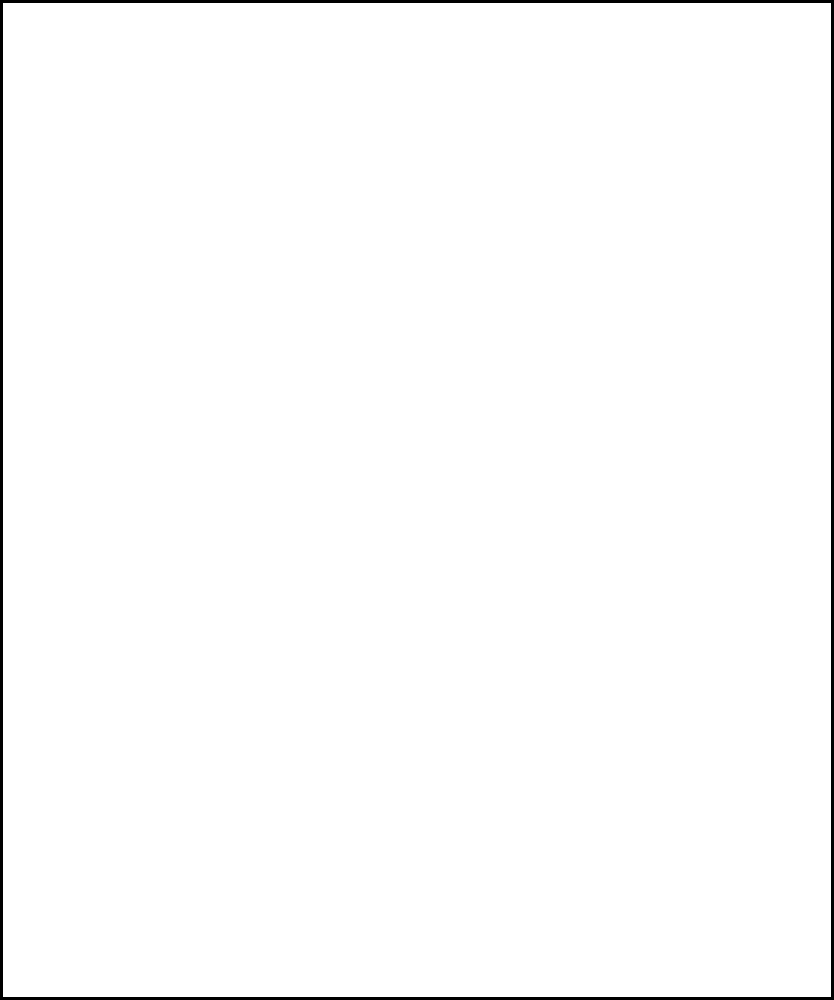A solar-heated room has dimensions of 5m x 6m with integrated heating panels in the flooring. The temperature distribution (in °C) is modeled by the function:

$$T(x,y) = 20 + 5\sin(\frac{\pi x}{5}) + 3\cos(\frac{\pi y}{6})$$

where $x$ and $y$ are the coordinates in meters. What is the maximum temperature difference between any two points in the room? To find the maximum temperature difference, we need to determine the highest and lowest temperatures in the room:

1. The base temperature is 20°C.

2. The $\sin$ term varies between -1 and 1, so it contributes between -5°C and +5°C.

3. The $\cos$ term varies between -1 and 1, so it contributes between -3°C and +3°C.

4. Maximum temperature occurs when both terms are at their maximum:
   $$T_{max} = 20 + 5 + 3 = 28°C$$

5. Minimum temperature occurs when both terms are at their minimum:
   $$T_{min} = 20 - 5 - 3 = 12°C$$

6. The maximum temperature difference is:
   $$\Delta T_{max} = T_{max} - T_{min} = 28°C - 12°C = 16°C$$
Answer: 16°C 